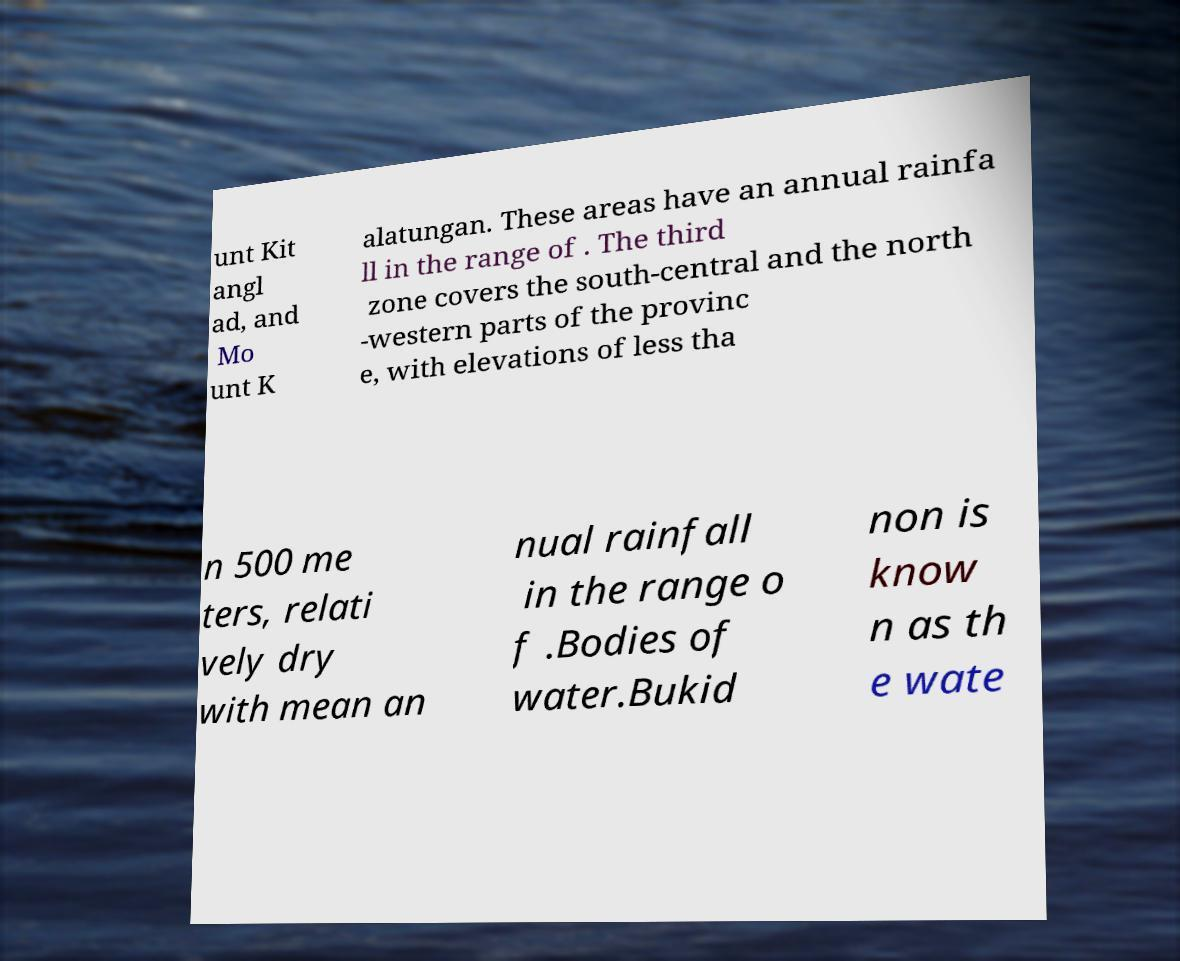Please read and relay the text visible in this image. What does it say? unt Kit angl ad, and Mo unt K alatungan. These areas have an annual rainfa ll in the range of . The third zone covers the south-central and the north -western parts of the provinc e, with elevations of less tha n 500 me ters, relati vely dry with mean an nual rainfall in the range o f .Bodies of water.Bukid non is know n as th e wate 